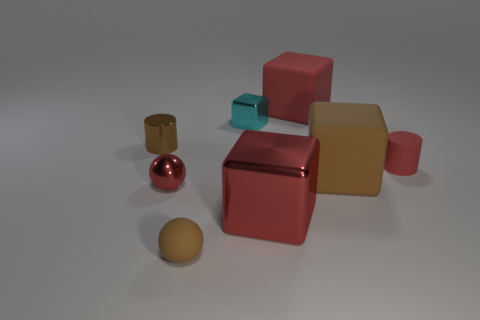Subtract all gray spheres. How many red blocks are left? 2 Subtract all small shiny blocks. How many blocks are left? 3 Subtract all cyan blocks. How many blocks are left? 3 Add 1 tiny blue rubber objects. How many objects exist? 9 Subtract all green blocks. Subtract all blue spheres. How many blocks are left? 4 Subtract all spheres. How many objects are left? 6 Add 8 brown cylinders. How many brown cylinders are left? 9 Add 6 large gray metallic cylinders. How many large gray metallic cylinders exist? 6 Subtract 1 red cylinders. How many objects are left? 7 Subtract all tiny brown metal cylinders. Subtract all brown blocks. How many objects are left? 6 